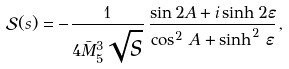<formula> <loc_0><loc_0><loc_500><loc_500>\mathcal { S } ( s ) = - \frac { 1 } { 4 \bar { M } _ { 5 } ^ { 3 } \sqrt { s } } \, \frac { \sin 2 A + i \sinh 2 \varepsilon } { \cos ^ { 2 } \, A + \sinh ^ { 2 } \, \varepsilon } \, ,</formula> 